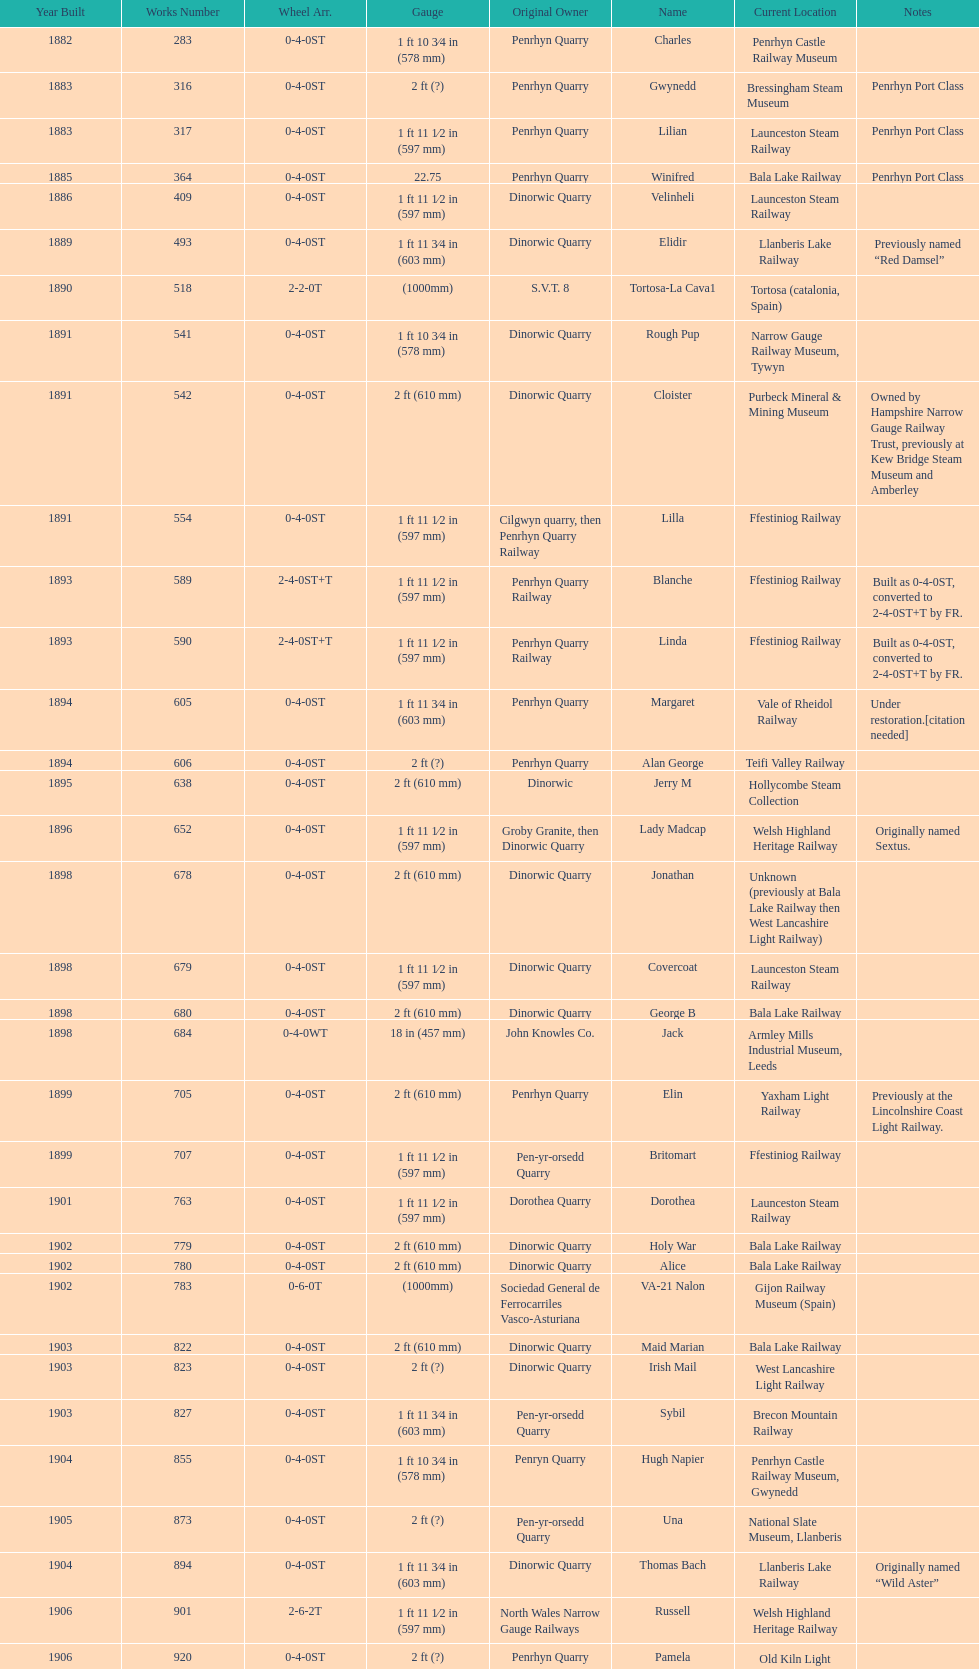Write the full table. {'header': ['Year Built', 'Works Number', 'Wheel Arr.', 'Gauge', 'Original Owner', 'Name', 'Current Location', 'Notes'], 'rows': [['1882', '283', '0-4-0ST', '1\xa0ft 10\xa03⁄4\xa0in (578\xa0mm)', 'Penrhyn Quarry', 'Charles', 'Penrhyn Castle Railway Museum', ''], ['1883', '316', '0-4-0ST', '2\xa0ft (?)', 'Penrhyn Quarry', 'Gwynedd', 'Bressingham Steam Museum', 'Penrhyn Port Class'], ['1883', '317', '0-4-0ST', '1\xa0ft 11\xa01⁄2\xa0in (597\xa0mm)', 'Penrhyn Quarry', 'Lilian', 'Launceston Steam Railway', 'Penrhyn Port Class'], ['1885', '364', '0-4-0ST', '22.75', 'Penrhyn Quarry', 'Winifred', 'Bala Lake Railway', 'Penrhyn Port Class'], ['1886', '409', '0-4-0ST', '1\xa0ft 11\xa01⁄2\xa0in (597\xa0mm)', 'Dinorwic Quarry', 'Velinheli', 'Launceston Steam Railway', ''], ['1889', '493', '0-4-0ST', '1\xa0ft 11\xa03⁄4\xa0in (603\xa0mm)', 'Dinorwic Quarry', 'Elidir', 'Llanberis Lake Railway', 'Previously named “Red Damsel”'], ['1890', '518', '2-2-0T', '(1000mm)', 'S.V.T. 8', 'Tortosa-La Cava1', 'Tortosa (catalonia, Spain)', ''], ['1891', '541', '0-4-0ST', '1\xa0ft 10\xa03⁄4\xa0in (578\xa0mm)', 'Dinorwic Quarry', 'Rough Pup', 'Narrow Gauge Railway Museum, Tywyn', ''], ['1891', '542', '0-4-0ST', '2\xa0ft (610\xa0mm)', 'Dinorwic Quarry', 'Cloister', 'Purbeck Mineral & Mining Museum', 'Owned by Hampshire Narrow Gauge Railway Trust, previously at Kew Bridge Steam Museum and Amberley'], ['1891', '554', '0-4-0ST', '1\xa0ft 11\xa01⁄2\xa0in (597\xa0mm)', 'Cilgwyn quarry, then Penrhyn Quarry Railway', 'Lilla', 'Ffestiniog Railway', ''], ['1893', '589', '2-4-0ST+T', '1\xa0ft 11\xa01⁄2\xa0in (597\xa0mm)', 'Penrhyn Quarry Railway', 'Blanche', 'Ffestiniog Railway', 'Built as 0-4-0ST, converted to 2-4-0ST+T by FR.'], ['1893', '590', '2-4-0ST+T', '1\xa0ft 11\xa01⁄2\xa0in (597\xa0mm)', 'Penrhyn Quarry Railway', 'Linda', 'Ffestiniog Railway', 'Built as 0-4-0ST, converted to 2-4-0ST+T by FR.'], ['1894', '605', '0-4-0ST', '1\xa0ft 11\xa03⁄4\xa0in (603\xa0mm)', 'Penrhyn Quarry', 'Margaret', 'Vale of Rheidol Railway', 'Under restoration.[citation needed]'], ['1894', '606', '0-4-0ST', '2\xa0ft (?)', 'Penrhyn Quarry', 'Alan George', 'Teifi Valley Railway', ''], ['1895', '638', '0-4-0ST', '2\xa0ft (610\xa0mm)', 'Dinorwic', 'Jerry M', 'Hollycombe Steam Collection', ''], ['1896', '652', '0-4-0ST', '1\xa0ft 11\xa01⁄2\xa0in (597\xa0mm)', 'Groby Granite, then Dinorwic Quarry', 'Lady Madcap', 'Welsh Highland Heritage Railway', 'Originally named Sextus.'], ['1898', '678', '0-4-0ST', '2\xa0ft (610\xa0mm)', 'Dinorwic Quarry', 'Jonathan', 'Unknown (previously at Bala Lake Railway then West Lancashire Light Railway)', ''], ['1898', '679', '0-4-0ST', '1\xa0ft 11\xa01⁄2\xa0in (597\xa0mm)', 'Dinorwic Quarry', 'Covercoat', 'Launceston Steam Railway', ''], ['1898', '680', '0-4-0ST', '2\xa0ft (610\xa0mm)', 'Dinorwic Quarry', 'George B', 'Bala Lake Railway', ''], ['1898', '684', '0-4-0WT', '18\xa0in (457\xa0mm)', 'John Knowles Co.', 'Jack', 'Armley Mills Industrial Museum, Leeds', ''], ['1899', '705', '0-4-0ST', '2\xa0ft (610\xa0mm)', 'Penrhyn Quarry', 'Elin', 'Yaxham Light Railway', 'Previously at the Lincolnshire Coast Light Railway.'], ['1899', '707', '0-4-0ST', '1\xa0ft 11\xa01⁄2\xa0in (597\xa0mm)', 'Pen-yr-orsedd Quarry', 'Britomart', 'Ffestiniog Railway', ''], ['1901', '763', '0-4-0ST', '1\xa0ft 11\xa01⁄2\xa0in (597\xa0mm)', 'Dorothea Quarry', 'Dorothea', 'Launceston Steam Railway', ''], ['1902', '779', '0-4-0ST', '2\xa0ft (610\xa0mm)', 'Dinorwic Quarry', 'Holy War', 'Bala Lake Railway', ''], ['1902', '780', '0-4-0ST', '2\xa0ft (610\xa0mm)', 'Dinorwic Quarry', 'Alice', 'Bala Lake Railway', ''], ['1902', '783', '0-6-0T', '(1000mm)', 'Sociedad General de Ferrocarriles Vasco-Asturiana', 'VA-21 Nalon', 'Gijon Railway Museum (Spain)', ''], ['1903', '822', '0-4-0ST', '2\xa0ft (610\xa0mm)', 'Dinorwic Quarry', 'Maid Marian', 'Bala Lake Railway', ''], ['1903', '823', '0-4-0ST', '2\xa0ft (?)', 'Dinorwic Quarry', 'Irish Mail', 'West Lancashire Light Railway', ''], ['1903', '827', '0-4-0ST', '1\xa0ft 11\xa03⁄4\xa0in (603\xa0mm)', 'Pen-yr-orsedd Quarry', 'Sybil', 'Brecon Mountain Railway', ''], ['1904', '855', '0-4-0ST', '1\xa0ft 10\xa03⁄4\xa0in (578\xa0mm)', 'Penryn Quarry', 'Hugh Napier', 'Penrhyn Castle Railway Museum, Gwynedd', ''], ['1905', '873', '0-4-0ST', '2\xa0ft (?)', 'Pen-yr-orsedd Quarry', 'Una', 'National Slate Museum, Llanberis', ''], ['1904', '894', '0-4-0ST', '1\xa0ft 11\xa03⁄4\xa0in (603\xa0mm)', 'Dinorwic Quarry', 'Thomas Bach', 'Llanberis Lake Railway', 'Originally named “Wild Aster”'], ['1906', '901', '2-6-2T', '1\xa0ft 11\xa01⁄2\xa0in (597\xa0mm)', 'North Wales Narrow Gauge Railways', 'Russell', 'Welsh Highland Heritage Railway', ''], ['1906', '920', '0-4-0ST', '2\xa0ft (?)', 'Penrhyn Quarry', 'Pamela', 'Old Kiln Light Railway', ''], ['1909', '994', '0-4-0ST', '2\xa0ft (?)', 'Penrhyn Quarry', 'Bill Harvey', 'Bressingham Steam Museum', 'previously George Sholto'], ['1918', '1312', '4-6-0T', '1\xa0ft\xa011\xa01⁄2\xa0in (597\xa0mm)', 'British War Department\\nEFOP #203', '---', 'Pampas Safari, Gravataí, RS, Brazil', '[citation needed]'], ['1918\\nor\\n1921?', '1313', '0-6-2T', '3\xa0ft\xa03\xa03⁄8\xa0in (1,000\xa0mm)', 'British War Department\\nUsina Leão Utinga #1\\nUsina Laginha #1', '---', 'Usina Laginha, União dos Palmares, AL, Brazil', '[citation needed]'], ['1920', '1404', '0-4-0WT', '18\xa0in (457\xa0mm)', 'John Knowles Co.', 'Gwen', 'Richard Farmer current owner, Northridge, California, USA', ''], ['1922', '1429', '0-4-0ST', '2\xa0ft (610\xa0mm)', 'Dinorwic', 'Lady Joan', 'Bredgar and Wormshill Light Railway', ''], ['1922', '1430', '0-4-0ST', '1\xa0ft 11\xa03⁄4\xa0in (603\xa0mm)', 'Dinorwic Quarry', 'Dolbadarn', 'Llanberis Lake Railway', ''], ['1937', '1859', '0-4-2T', '2\xa0ft (?)', 'Umtwalumi Valley Estate, Natal', '16 Carlisle', 'South Tynedale Railway', ''], ['1940', '2075', '0-4-2T', '2\xa0ft (?)', 'Chaka’s Kraal Sugar Estates, Natal', 'Chaka’s Kraal No. 6', 'North Gloucestershire Railway', ''], ['1954', '3815', '2-6-2T', '2\xa0ft 6\xa0in (762\xa0mm)', 'Sierra Leone Government Railway', '14', 'Welshpool and Llanfair Light Railway', ''], ['1971', '3902', '0-4-2ST', '2\xa0ft (610\xa0mm)', 'Trangkil Sugar Mill, Indonesia', 'Trangkil No.4', 'Statfold Barn Railway', 'Converted from 750\xa0mm (2\xa0ft\xa05\xa01⁄2\xa0in) gauge. Last steam locomotive to be built by Hunslet, and the last industrial steam locomotive built in Britain.']]} What is the difference in gauge between works numbers 541 and 542? 32 mm. 